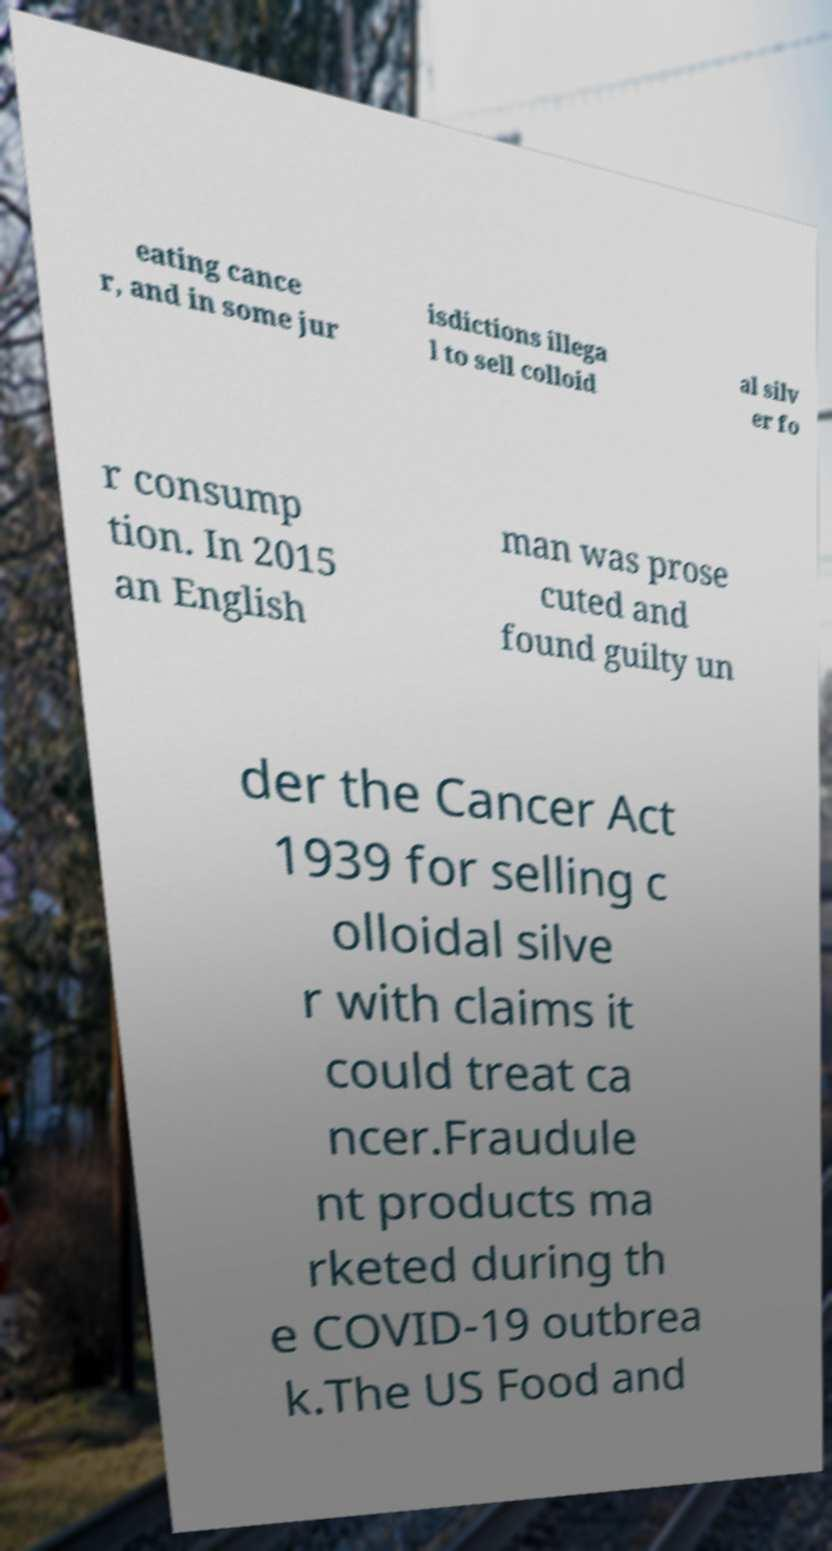Please identify and transcribe the text found in this image. eating cance r, and in some jur isdictions illega l to sell colloid al silv er fo r consump tion. In 2015 an English man was prose cuted and found guilty un der the Cancer Act 1939 for selling c olloidal silve r with claims it could treat ca ncer.Fraudule nt products ma rketed during th e COVID-19 outbrea k.The US Food and 